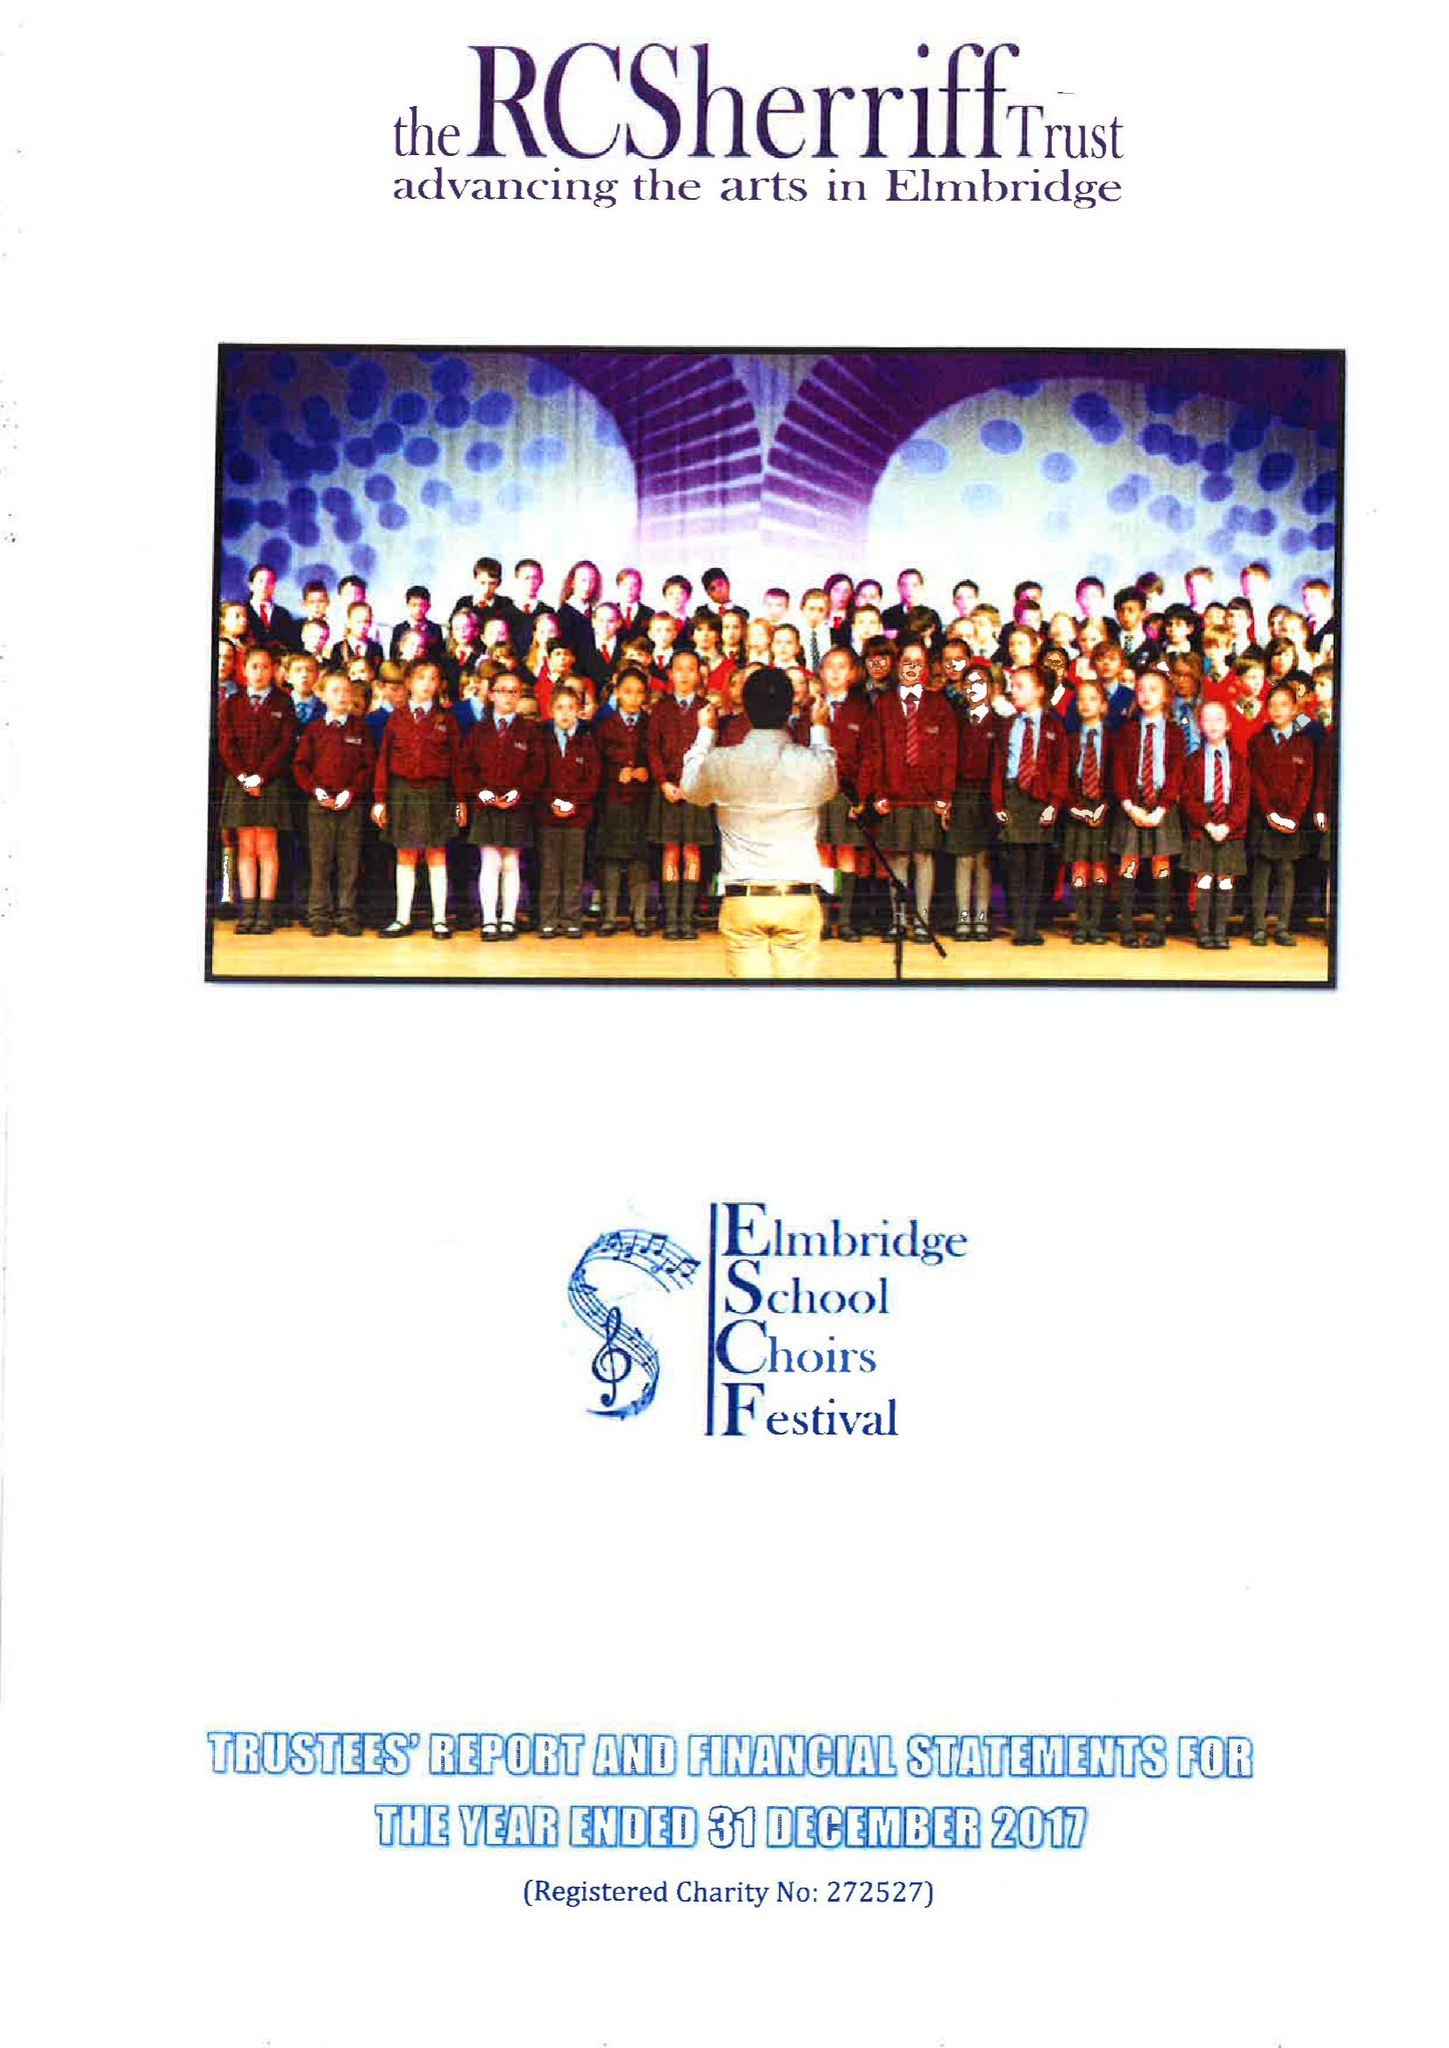What is the value for the address__post_town?
Answer the question using a single word or phrase. ESHER 